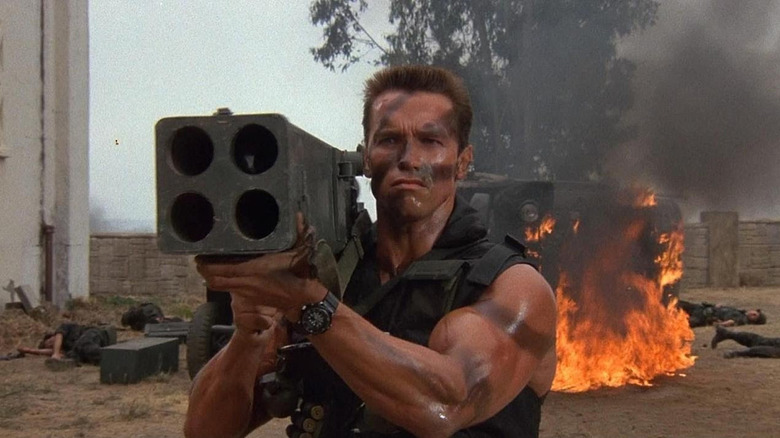Can you elaborate on the elements of the picture provided? The image captures a dramatic and intense scene featuring a man, portrayed by an actor known for his roles in action movies, standing against a war-torn backdrop. He is dressed in a dark, sleeveless tactical vest and face paint, holding what appears to be a large, multi-barrel rocket launcher. His expression is stern and focused, suggesting a high-stakes situation. The background shows smoke and fire, indicating recent battle activity, which adds to the urgency and gravity of the scene. 